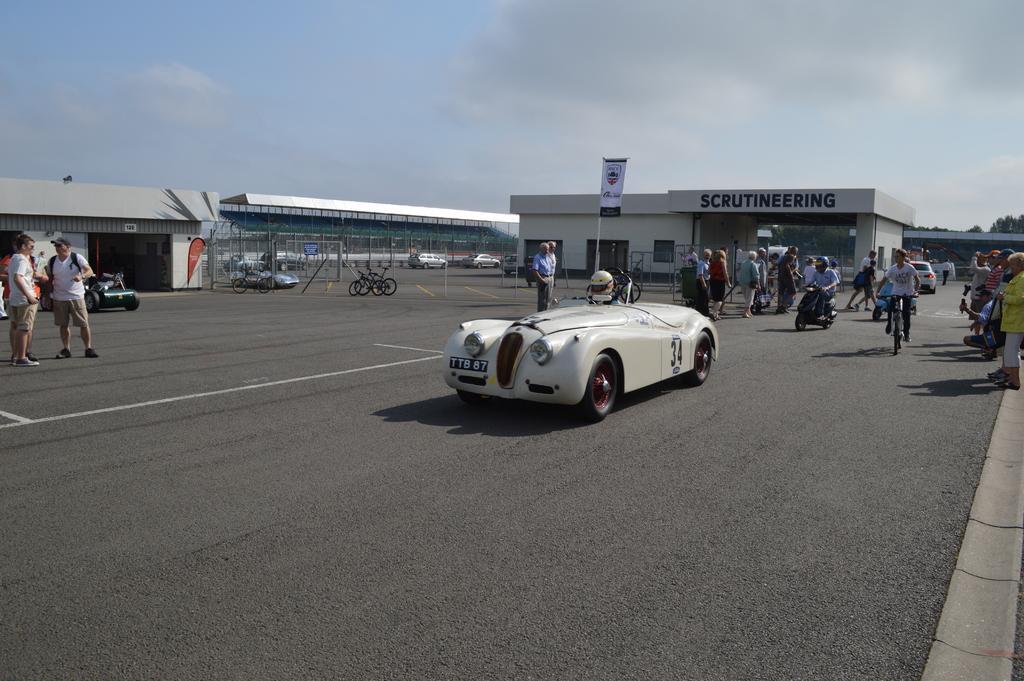How would you summarize this image in a sentence or two? In this picture there is a car in the center of the image, there are people on the right and left side of the image, there are other cars and bicycles in the image, there are warehouses in the image, there are trees in the background area of the image, there is a flag in the image. 